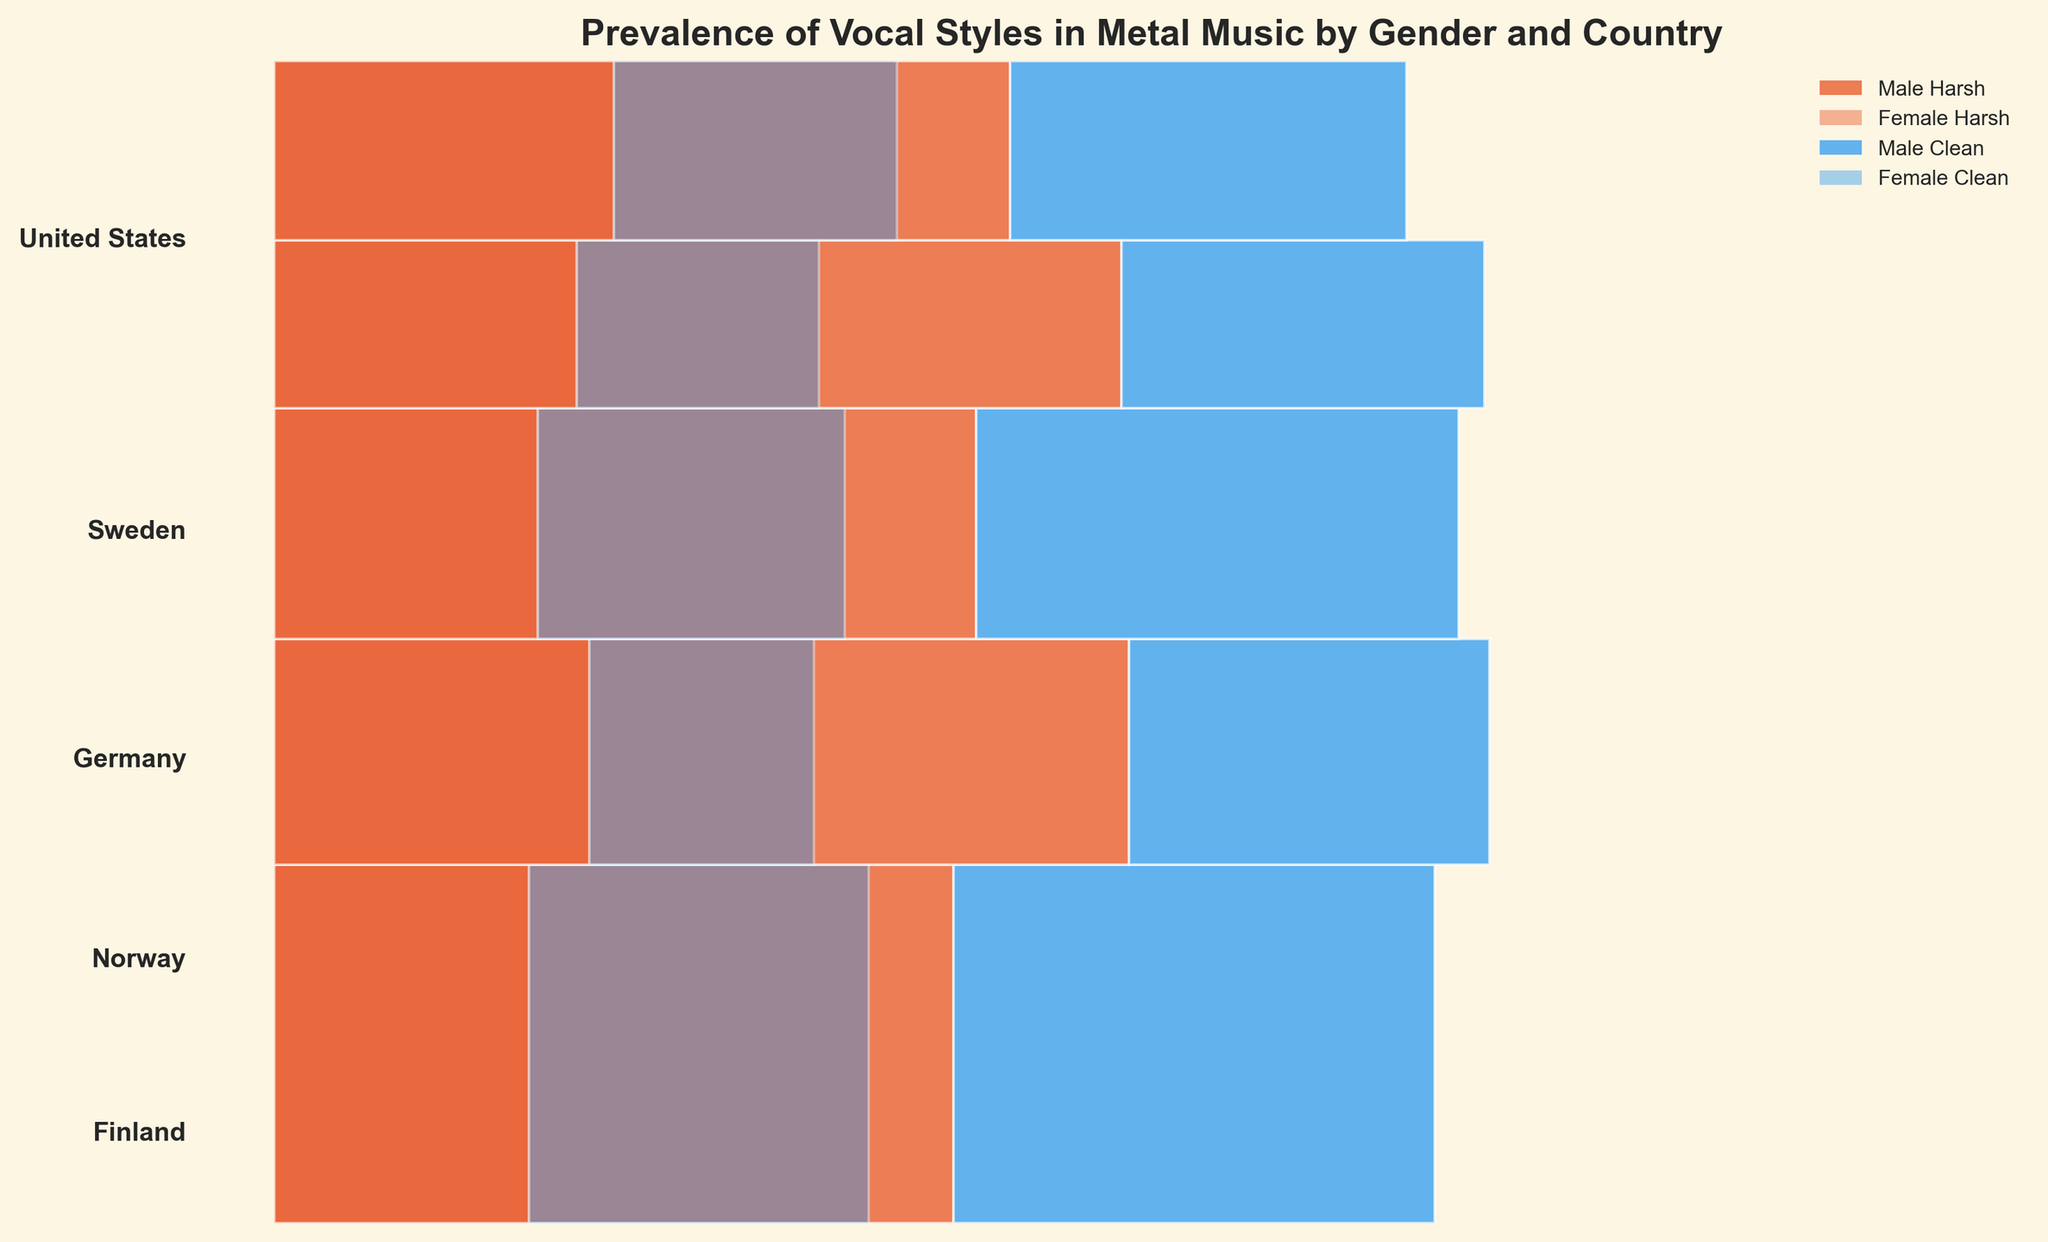Which country is the most represented in this mosaic plot? The height of each segment for a country is proportional to the total number of vocal style counts from that country. The United States has the tallest segment, meaning it has the most representation in the data.
Answer: United States Which gender predominantly uses harsh vocal styles in Sweden? For each country, the mosaic plot uses different colors to represent harsh and clean vocal styles and varying opacities to show gender. In Sweden, the darker rectangle (darker hue indicates male) representing 'Harsh' (shown in specific color) has more area compared to its female counterpart.
Answer: Male How does the representation of female vocal styles differ between Norway and Finland? Look at the rectangles representing 'Female' vocal styles in Norway and Finland. Observe the relative sizes of ‘Harsh’ and ‘Clean’ styles for females in each country. Norway has a smaller share of both harsh and clean styles for females compared to Finland.
Answer: Norway has a smaller representation Which gender has more clean vocal representation in Germany, and by how much? Look at the sections of the mosaic plot for Germany. Compare the areas of the lighter color rectangles (female) to the darker color rectangles (male) representing ‘Clean’ vocal styles. The male representation is visually larger.
Answer: Male; by a larger area What is the total representation of harsh female vocalists across all countries? Sum the areas of all rectangles representing 'Female' (lighter shade) 'Harsh' (specific color) vocal styles across every country.
Answer: 165 Between the United States and Sweden, which country has a higher representation of clean male vocal styles? Compare the size of rectangles representing 'Male' (darker shade) 'Clean' (specific color) vocal styles in the United States and Sweden. The United States segment is larger.
Answer: United States Which group has the least representation in Finland? Identify the rectangle with the smallest area within the Finland segment. The smallest section for Finland is 'Female' (lighter shade) with 'Clean' (specific color) vocal style.
Answer: Female Clean Is the share of male harsh vocalists greater in Germany or Norway? Compare the sections of the mosaic plot for male harsh vocalists in Germany and Norway. The rectangle for Germany is relatively larger.
Answer: Germany Does any country have an equal representation of harsh and clean vocal styles for females? Check if any country's 'Female' (lighter shade) sections are evenly split between 'Harsh' (specific color) and 'Clean' (specific color) vocal styles. Germany's representation of female vocalists in harsh and clean styles appears approximately equal.
Answer: Germany How do the male and female vocal style representations compare in the United States? Analyze the United States section, comparing the relative areas of male and female (darker and lighter shades) and 'Harsh' and 'Clean' vocal styles (specific colors). Males dominate in both vocal styles compared to females.
Answer: Males dominate 